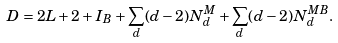<formula> <loc_0><loc_0><loc_500><loc_500>D = 2 L + 2 + I _ { B } + \sum _ { d } ( d - 2 ) N _ { d } ^ { M } + \sum _ { d } ( d - 2 ) N _ { d } ^ { M B } .</formula> 